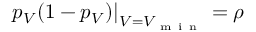<formula> <loc_0><loc_0><loc_500><loc_500>p _ { V } ( 1 - p _ { V } ) \right | _ { V = V _ { m i n } } = \rho</formula> 